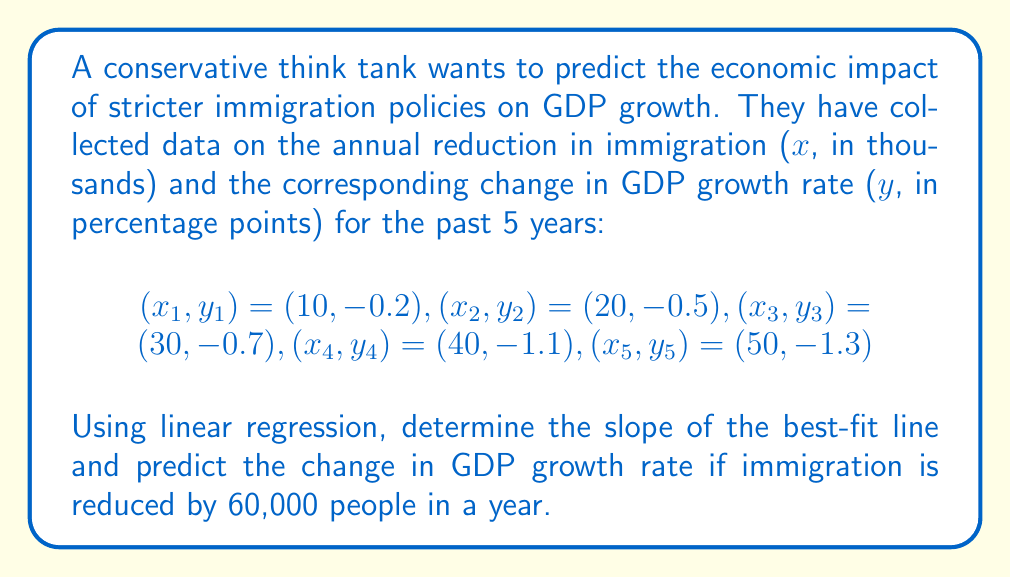Can you solve this math problem? To solve this problem, we'll use the linear regression formula:

$$y = mx + b$$

Where $m$ is the slope and $b$ is the y-intercept.

1. Calculate the means of x and y:
   $$\bar{x} = \frac{10 + 20 + 30 + 40 + 50}{5} = 30$$
   $$\bar{y} = \frac{-0.2 + (-0.5) + (-0.7) + (-1.1) + (-1.3)}{5} = -0.76$$

2. Calculate the slope (m):
   $$m = \frac{\sum_{i=1}^{n} (x_i - \bar{x})(y_i - \bar{y})}{\sum_{i=1}^{n} (x_i - \bar{x})^2}$$

   Numerator: $(-20)(-0.56) + (-10)(-0.26) + (0)(0.06) + (10)(0.34) + (20)(0.54) = 25.4$
   Denominator: $(-20)^2 + (-10)^2 + (0)^2 + (10)^2 + (20)^2 = 1000$

   $$m = \frac{25.4}{1000} = -0.0254$$

3. Calculate the y-intercept (b):
   $$b = \bar{y} - m\bar{x} = -0.76 - (-0.0254)(30) = -0.002$$

4. The linear regression equation is:
   $$y = -0.0254x - 0.002$$

5. To predict the change in GDP growth rate for x = 60:
   $$y = -0.0254(60) - 0.002 = -1.526$$

Therefore, if immigration is reduced by 60,000 people in a year, the predicted change in GDP growth rate would be -1.526 percentage points.
Answer: Slope: -0.0254
Predicted change in GDP growth rate: -1.526 percentage points 